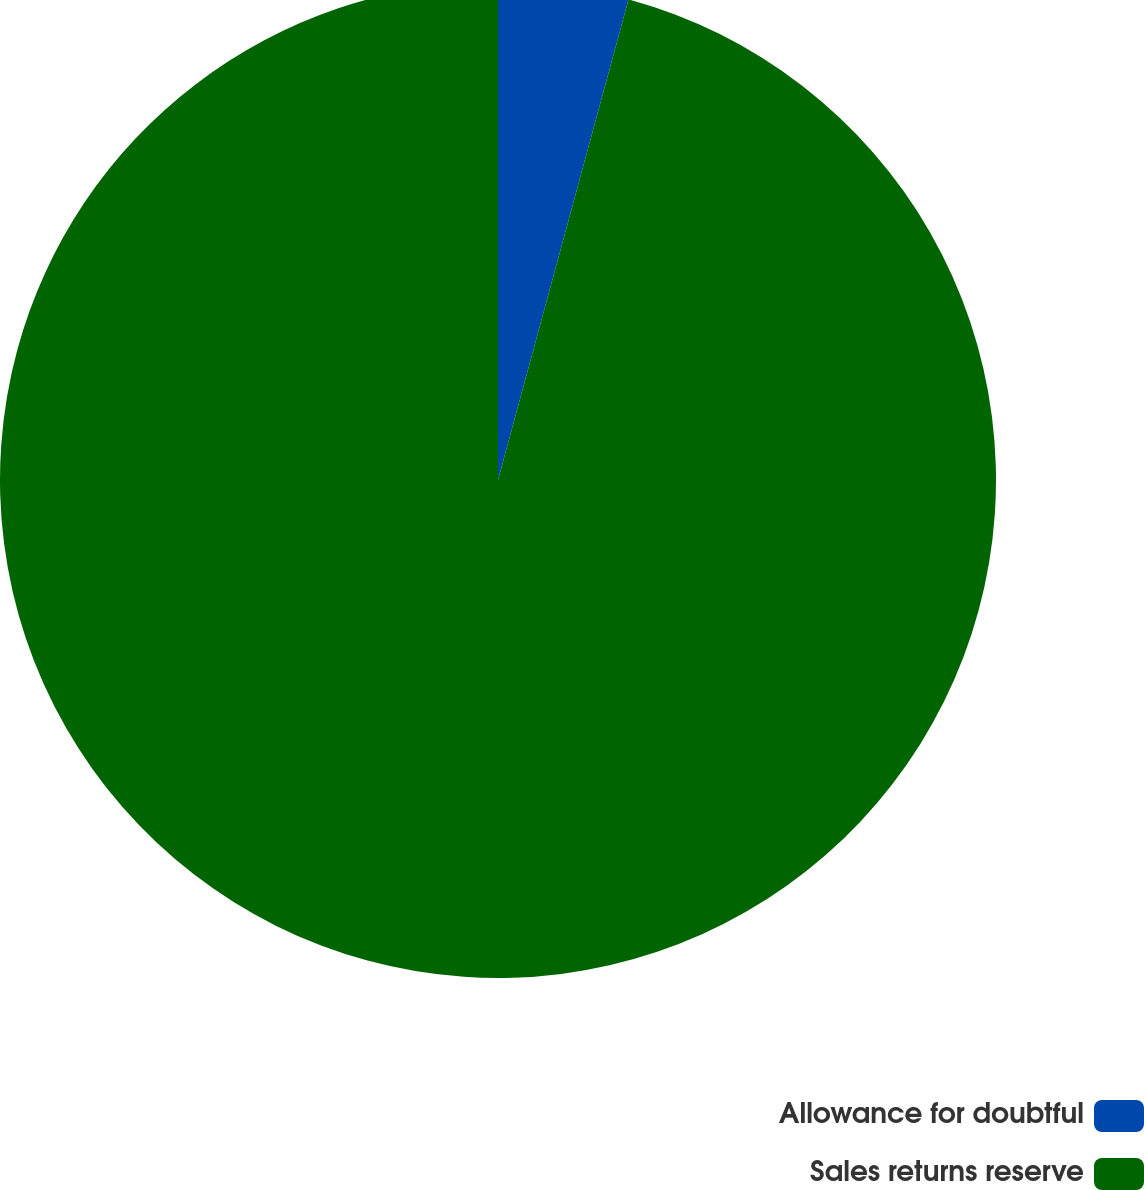Convert chart. <chart><loc_0><loc_0><loc_500><loc_500><pie_chart><fcel>Allowance for doubtful<fcel>Sales returns reserve<nl><fcel>4.22%<fcel>95.78%<nl></chart> 